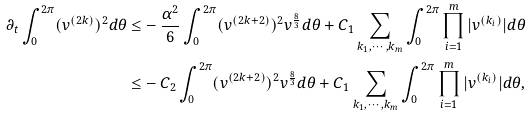<formula> <loc_0><loc_0><loc_500><loc_500>\partial _ { t } \int _ { 0 } ^ { 2 \pi } ( v ^ { ( 2 k ) } ) ^ { 2 } d \theta \leq & - \frac { \alpha ^ { 2 } } 6 \int _ { 0 } ^ { 2 \pi } ( v ^ { ( 2 k + 2 ) } ) ^ { 2 } v ^ { \frac { 8 } { 3 } } d \theta + C _ { 1 } \sum _ { k _ { 1 } , \cdots , k _ { m } } \int _ { 0 } ^ { 2 \pi } \prod _ { i = 1 } ^ { m } | v ^ { ( k _ { i } ) } | d \theta \\ \leq & - C _ { 2 } \int _ { 0 } ^ { 2 \pi } ( v ^ { ( 2 k + 2 ) } ) ^ { 2 } v ^ { \frac { 8 } { 3 } } d \theta + C _ { 1 } \sum _ { k _ { 1 } , \cdots , k _ { m } } \int _ { 0 } ^ { 2 \pi } \prod _ { i = 1 } ^ { m } | v ^ { ( k _ { i } ) } | d \theta ,</formula> 